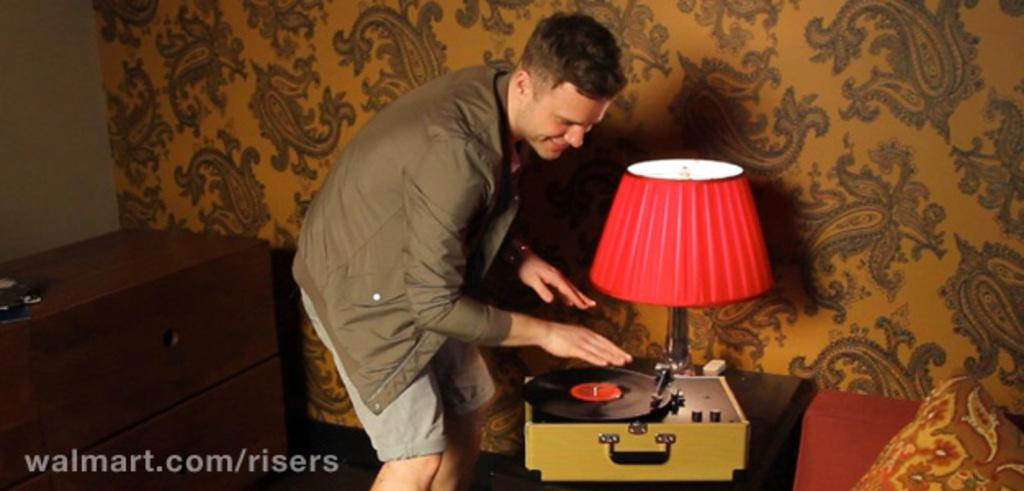What object is the man standing near in the image? The man is standing near a modern gramophone. What other object is located near the gramophone? There is a table lamp near the gramophone. What can be seen on the left side of the image? There is a table on the left side of the image. What can be observed in the background of the image? There is a wall with wallpaper in the background. How many ants can be seen crawling on the gramophone in the image? There are no ants present on the gramophone or in the image. What type of fiction is the man reading in the image? There is no book or any form of fiction present in the image. 